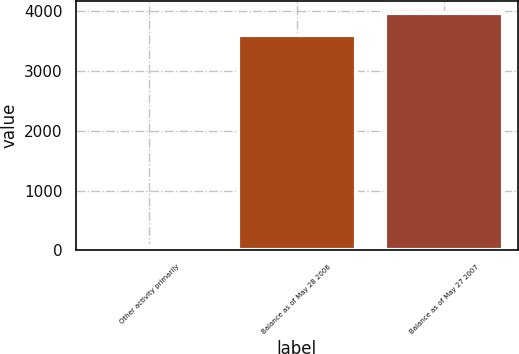<chart> <loc_0><loc_0><loc_500><loc_500><bar_chart><fcel>Other activity primarily<fcel>Balance as of May 28 2006<fcel>Balance as of May 27 2007<nl><fcel>75<fcel>3607.1<fcel>3969<nl></chart> 